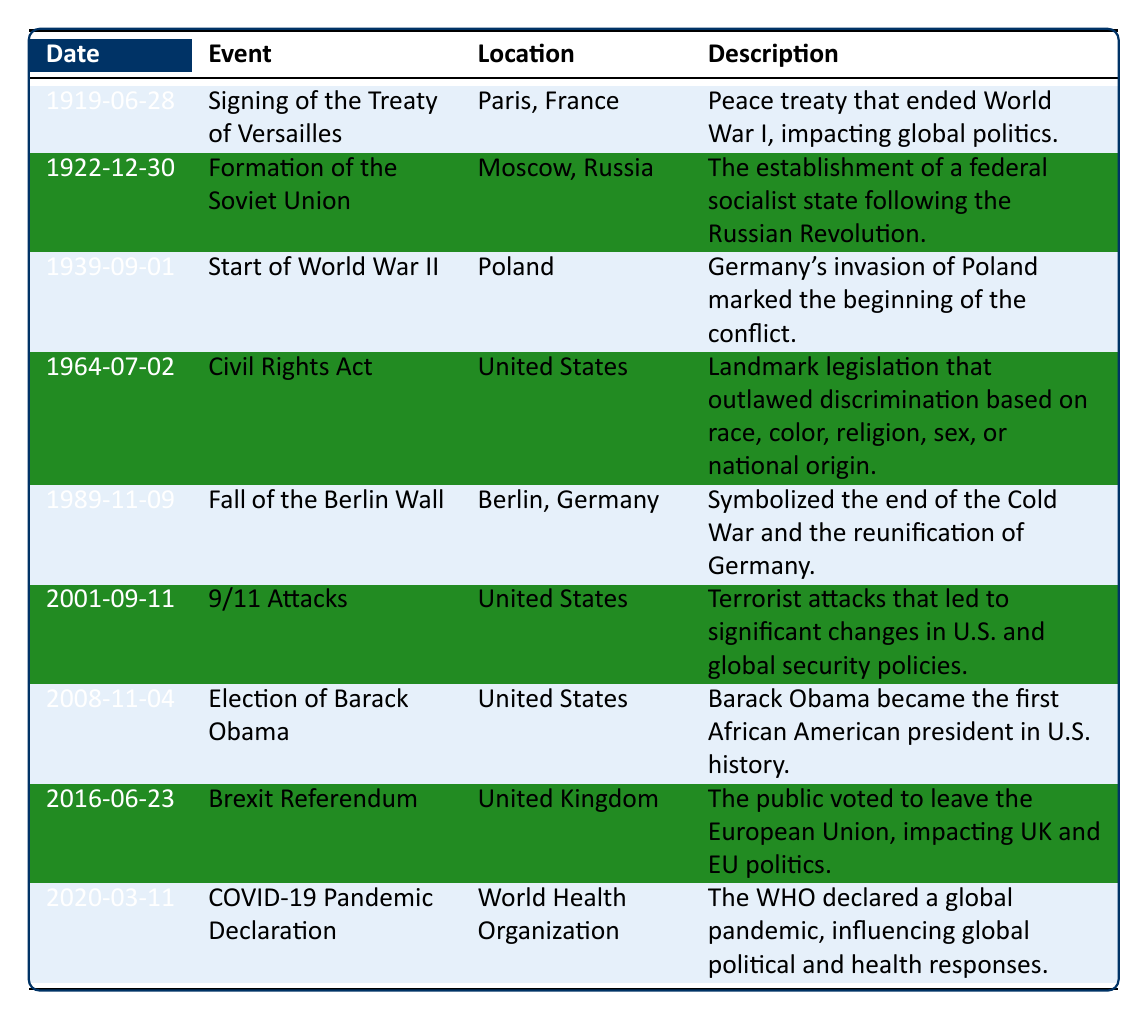What is the date of the signing of the Treaty of Versailles? The table lists the event "Signing of the Treaty of Versailles" along with its date, which is clearly stated as "1919-06-28."
Answer: 1919-06-28 Where did the Fall of the Berlin Wall take place? The table shows that the event "Fall of the Berlin Wall" occurred at "Berlin, Germany," as noted in the location column.
Answer: Berlin, Germany Did the Civil Rights Act happen before the formation of the Soviet Union? By looking at the dates in the table, the Civil Rights Act is dated "1964-07-02" and the formation of the Soviet Union is on "1922-12-30". Since 1964 is after 1922, the statement is false.
Answer: No How many events occurred in the United States? The table lists three events specifically located in the United States: "Civil Rights Act," "9/11 Attacks," and "Election of Barack Obama." Thus, counting those gives a total of three events.
Answer: 3 What is the difference in years between the start of World War II and the fall of the Berlin Wall? The start of World War II is on "1939-09-01" and the fall of the Berlin Wall is on "1989-11-09." Calculating the difference: 1989 - 1939 = 50 years.
Answer: 50 years Which event occurred most recently according to the table? By reviewing the dates, "COVID-19 Pandemic Declaration" is listed as happening on "2020-03-11," which is the latest date in the table.
Answer: COVID-19 Pandemic Declaration Is there any event listed that resulted in changes to global security policies? The table indicates that the "9/11 Attacks" led to significant changes in U.S. and global security policies, therefore confirming the statement is true.
Answer: Yes What was the common factor among the events listed as occurring in the United Kingdom? According to the table, only one event, the "Brexit Referendum," is listed under the United Kingdom, meaning there is no common factor for multiple events.
Answer: There is only one event What event directly followed the formation of the Soviet Union by only a few years? After examining the events, "Start of World War II" on "1939-09-01" occurred 17 years after the formation of the Soviet Union on "1922-12-30." It can be stated that there is a significant gap, so the answer is that no event follows closely.
Answer: No event closely followed 